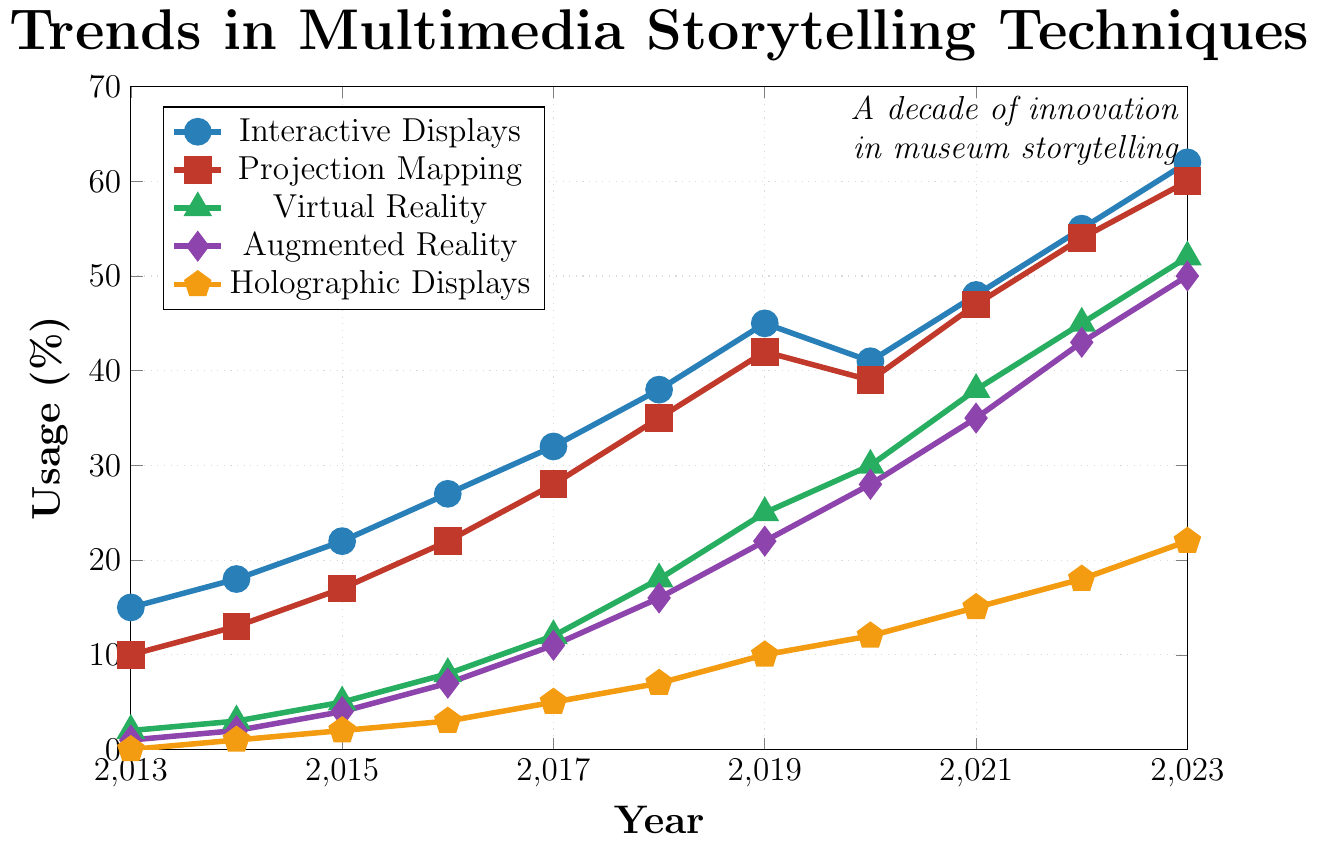What storytelling technique had the highest usage in 2023? Examine the highest data point at the far right side of the chart in 2023.
Answer: Interactive Displays How did the usage of Projection Mapping change from 2018 to 2019? Look at the y-values for Projection Mapping in 2018 (35) and 2019 (42) on the chart. Calculate the difference: 42 - 35 = 7.
Answer: Increased by 7% Which technique showed the most significant growth between 2013 and 2023? Identify the data points for each technique in 2013 and 2023, then calculate the difference for each. Interactive Displays: 62 - 15 = 47, Projection Mapping: 60 - 10 = 50, Virtual Reality: 52 - 2 = 50, Augmented Reality: 50 - 1 = 49, Holographic Displays: 22 - 0 = 22.
Answer: Projection Mapping and Virtual Reality What is the median usage percentage of Augmented Reality across the entire decade? List the data points for Augmented Reality: 1, 2, 4, 7, 11, 16, 22, 28, 35, 43, 50. Since there are 11 data points, the median is the 6th value, which is 16.
Answer: 16% In which year did Interactive Displays surpass 40% usage? Find the first data point for Interactive Displays above 40% on the chart. This occurs in 2019.
Answer: 2019 What is the average usage percentage of Virtual Reality over the last three years? Add the usage percentages of Virtual Reality for 2021, 2022, and 2023: 38 + 45 + 52 = 135. Divide by 3: 135 / 3 = 45.
Answer: 45% Comparison between Augmented Reality and Holographic Displays in 2020, which had higher usage? Locate the 2020 values for Augmented Reality and Holographic Displays: 28 and 12, respectively.
Answer: Augmented Reality (28%) Which color represents Holographic Displays in the chart? Identify the legend symbol matching Holographic Displays. It is represented by the color orange.
Answer: Orange What's the difference in usage percentages between the highest and lowest used techniques in 2021? Identify the highest (Interactive Displays at 48) and the lowest (Holographic Displays at 15) data points for 2021. Calculate the difference: 48 - 15 = 33.
Answer: 33% Which technique had a consistent increase in usage every year without any decline? Examine the trends for each technique. Holographic Displays show a year-over-year increase without any declines.
Answer: Holographic Displays 